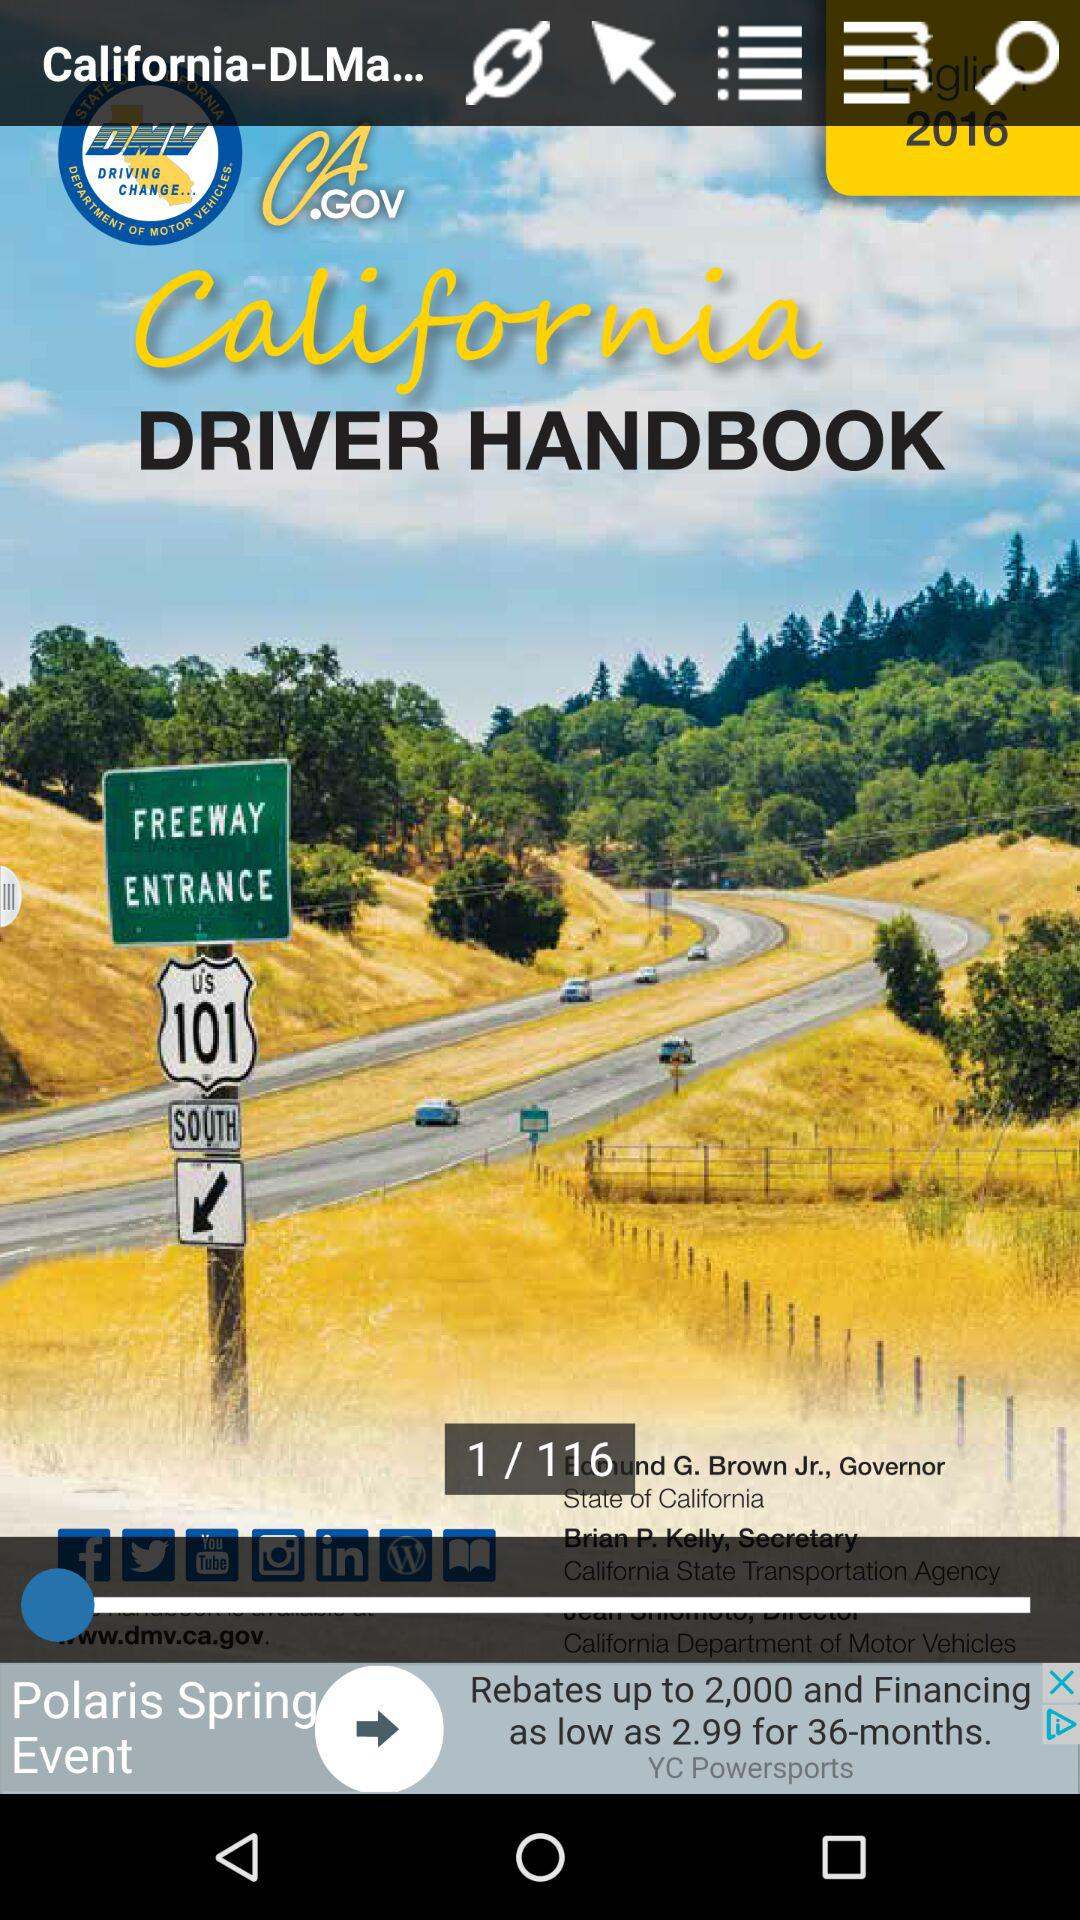Which page am I on now? You are now on page 1. 